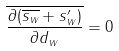<formula> <loc_0><loc_0><loc_500><loc_500>\overline { \frac { \partial ( \overline { s _ { w } } + s _ { w } ^ { \prime } ) } { \partial d _ { w } } } = 0</formula> 